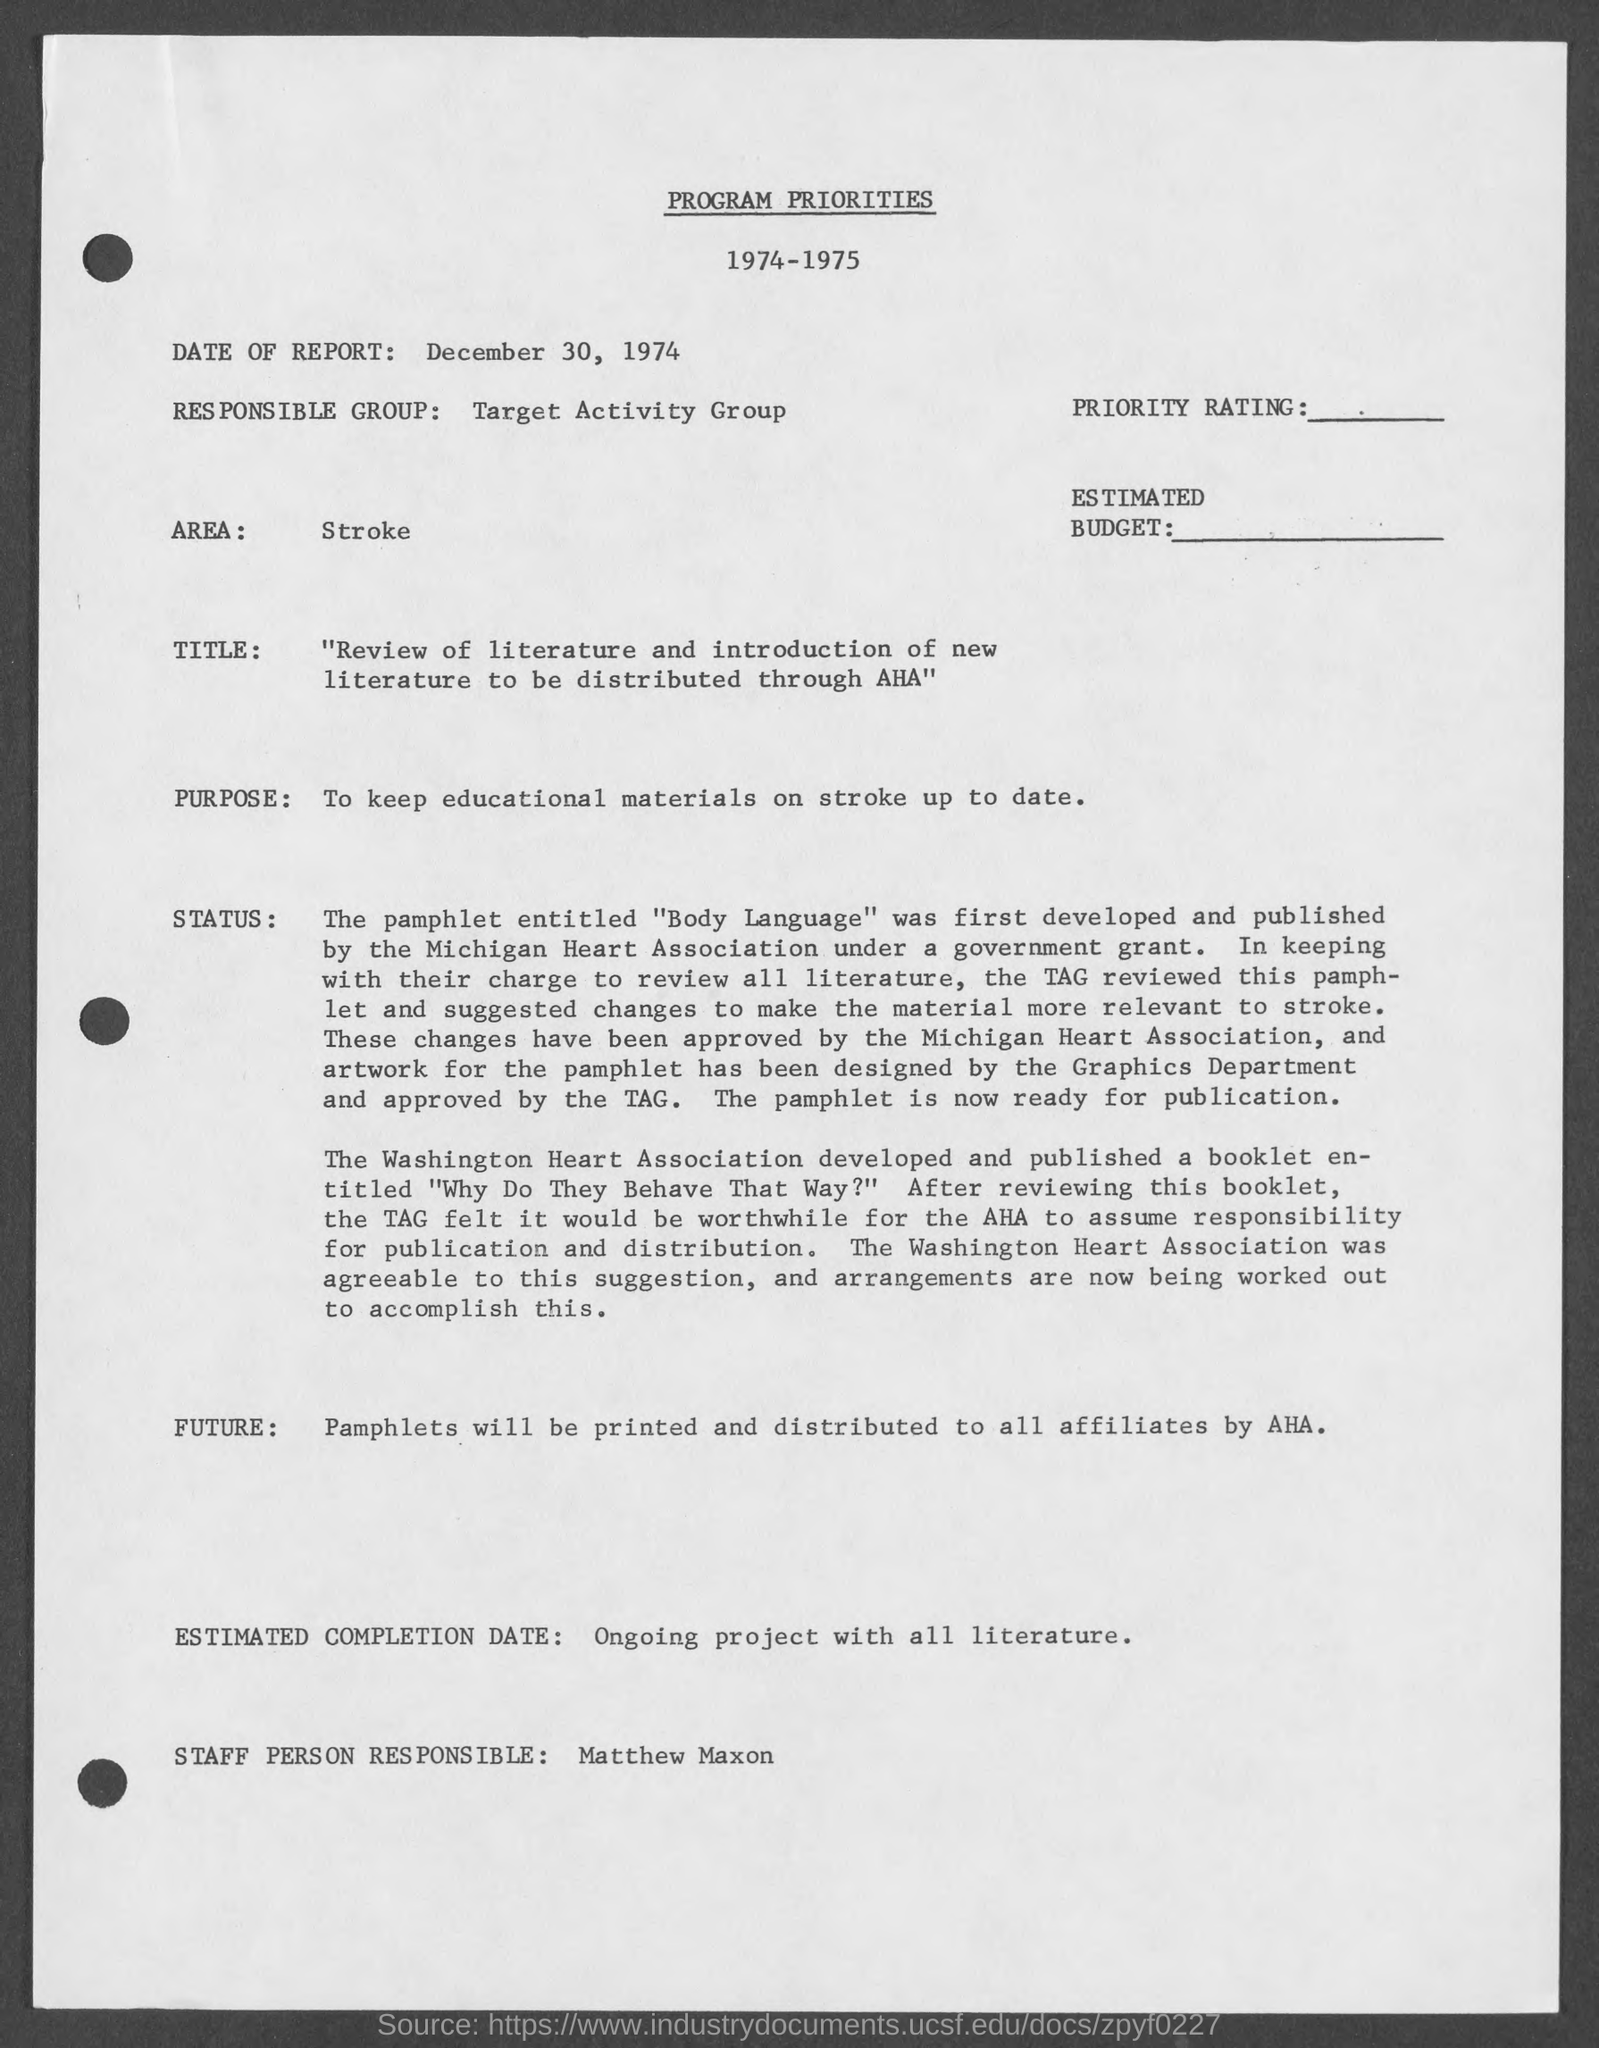What is the date of report given in the document?
Provide a short and direct response. December 30, 1974. Who is the responsible group mentioned in the document?
Ensure brevity in your answer.  Target Activity Group. What is the Purpose of the program mentioned in the document?
Provide a succinct answer. To keep educational materials on stroke up to date. Which Area is mentioned in the document?
Give a very brief answer. Stroke. 